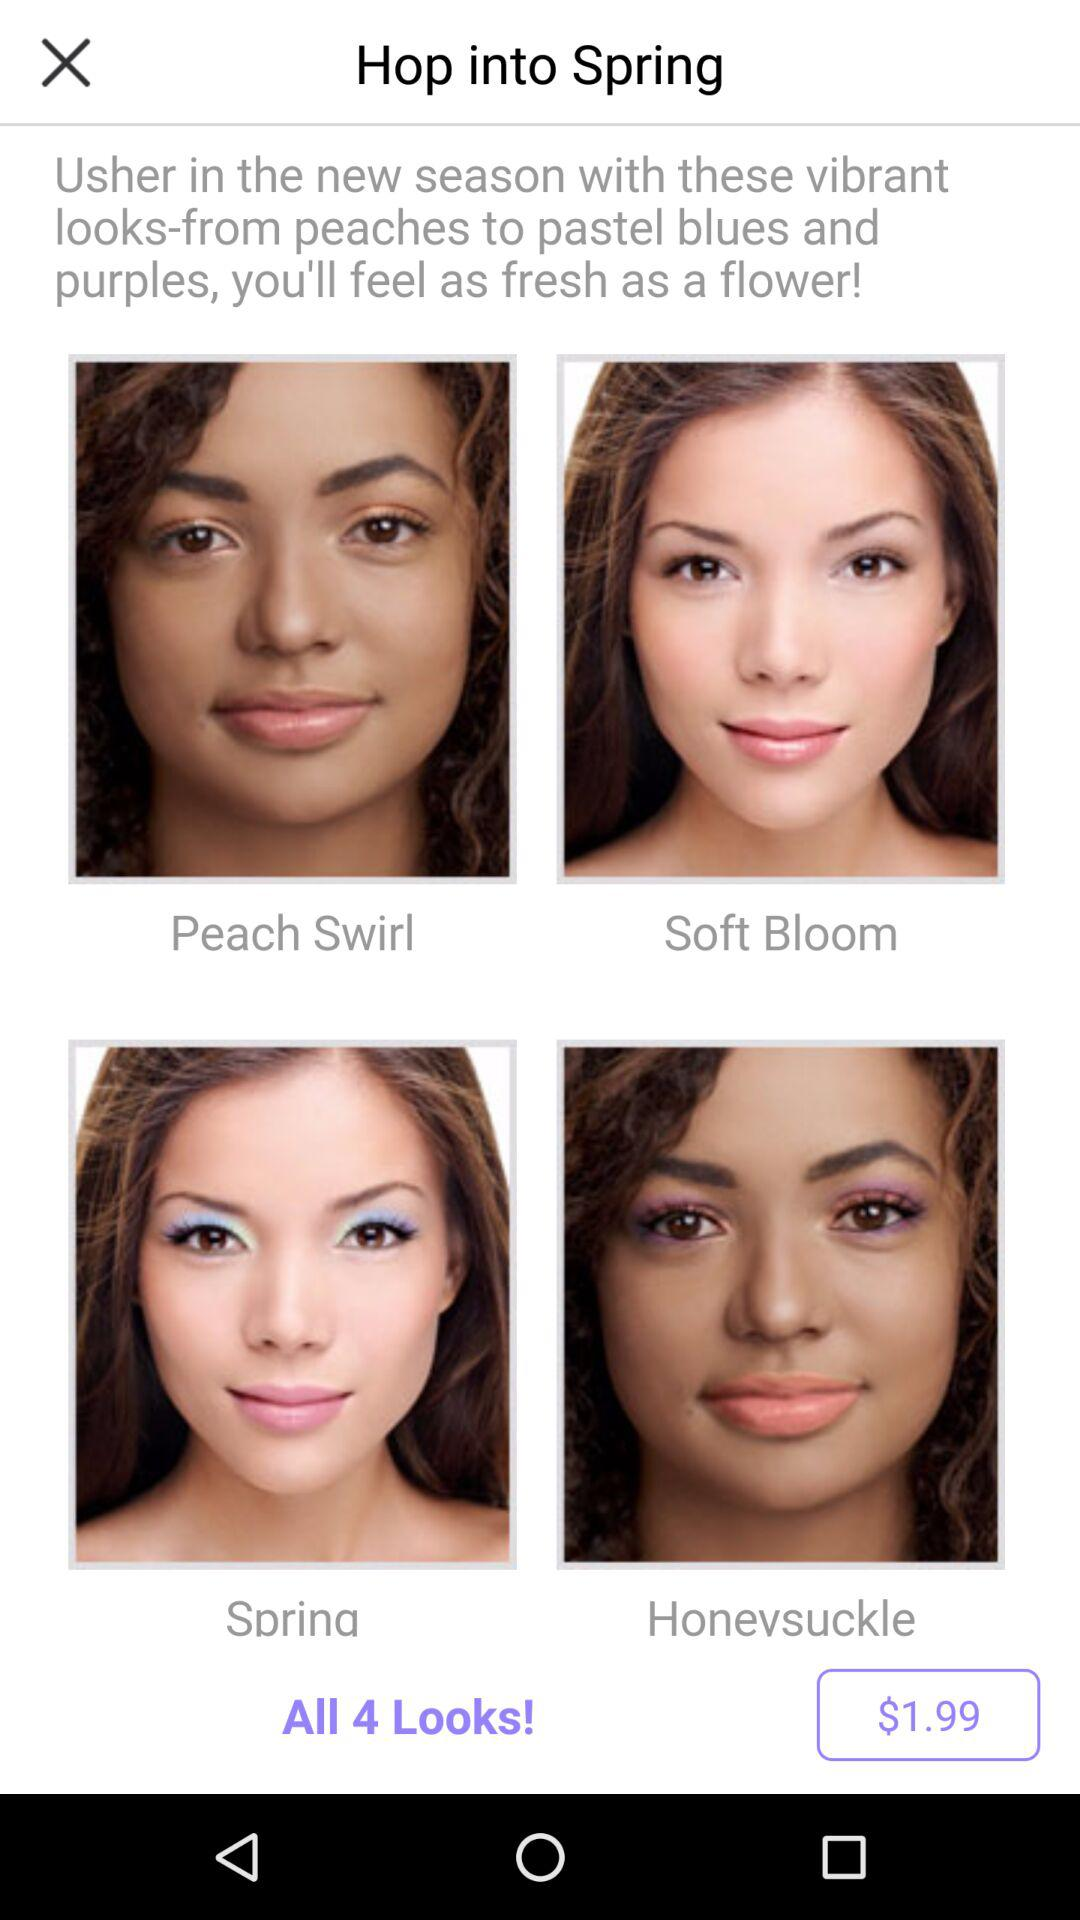How many looks are available to try out in the new season?
Answer the question using a single word or phrase. 4 